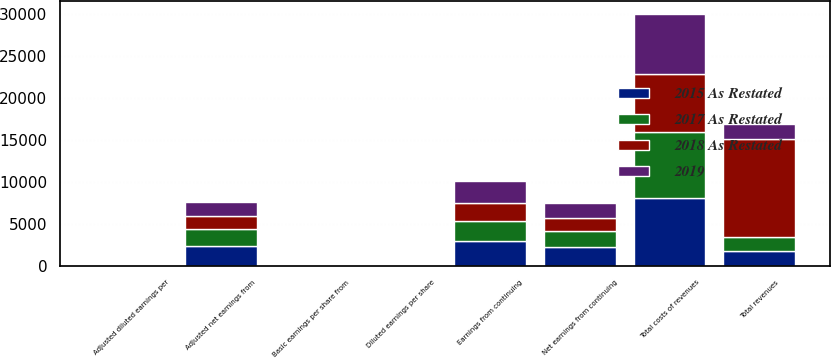<chart> <loc_0><loc_0><loc_500><loc_500><stacked_bar_chart><ecel><fcel>Total revenues<fcel>Total costs of revenues<fcel>Earnings from continuing<fcel>Net earnings from continuing<fcel>Adjusted net earnings from<fcel>Basic earnings per share from<fcel>Diluted earnings per share<fcel>Adjusted diluted earnings per<nl><fcel>2015 As Restated<fcel>1719.4<fcel>8086.6<fcel>3005.6<fcel>2292.8<fcel>2384.3<fcel>5.27<fcel>5.24<fcel>5.45<nl><fcel>2017 As Restated<fcel>1719.4<fcel>7810.9<fcel>2282.6<fcel>1884.9<fcel>2007.3<fcel>4.28<fcel>4.25<fcel>4.53<nl><fcel>2019<fcel>1719.4<fcel>7244.5<fcel>2616.9<fcel>1787.8<fcel>1719.4<fcel>3.99<fcel>3.97<fcel>3.82<nl><fcel>2018 As Restated<fcel>11667.8<fcel>6876.1<fcel>2234.7<fcel>1493.4<fcel>1494.8<fcel>3.27<fcel>3.25<fcel>3.26<nl></chart> 